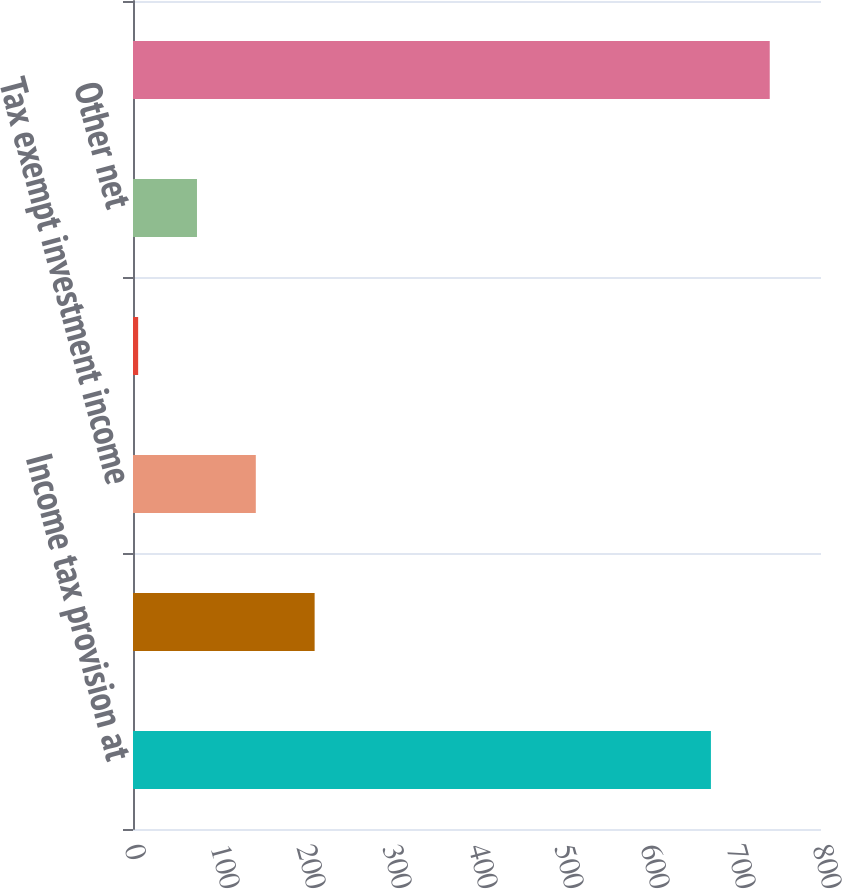<chart> <loc_0><loc_0><loc_500><loc_500><bar_chart><fcel>Income tax provision at<fcel>States net of federal benefit<fcel>Tax exempt investment income<fcel>Nondeductible executive<fcel>Other net<fcel>Provision for income taxes<nl><fcel>672<fcel>211.2<fcel>142.8<fcel>6<fcel>74.4<fcel>740.4<nl></chart> 